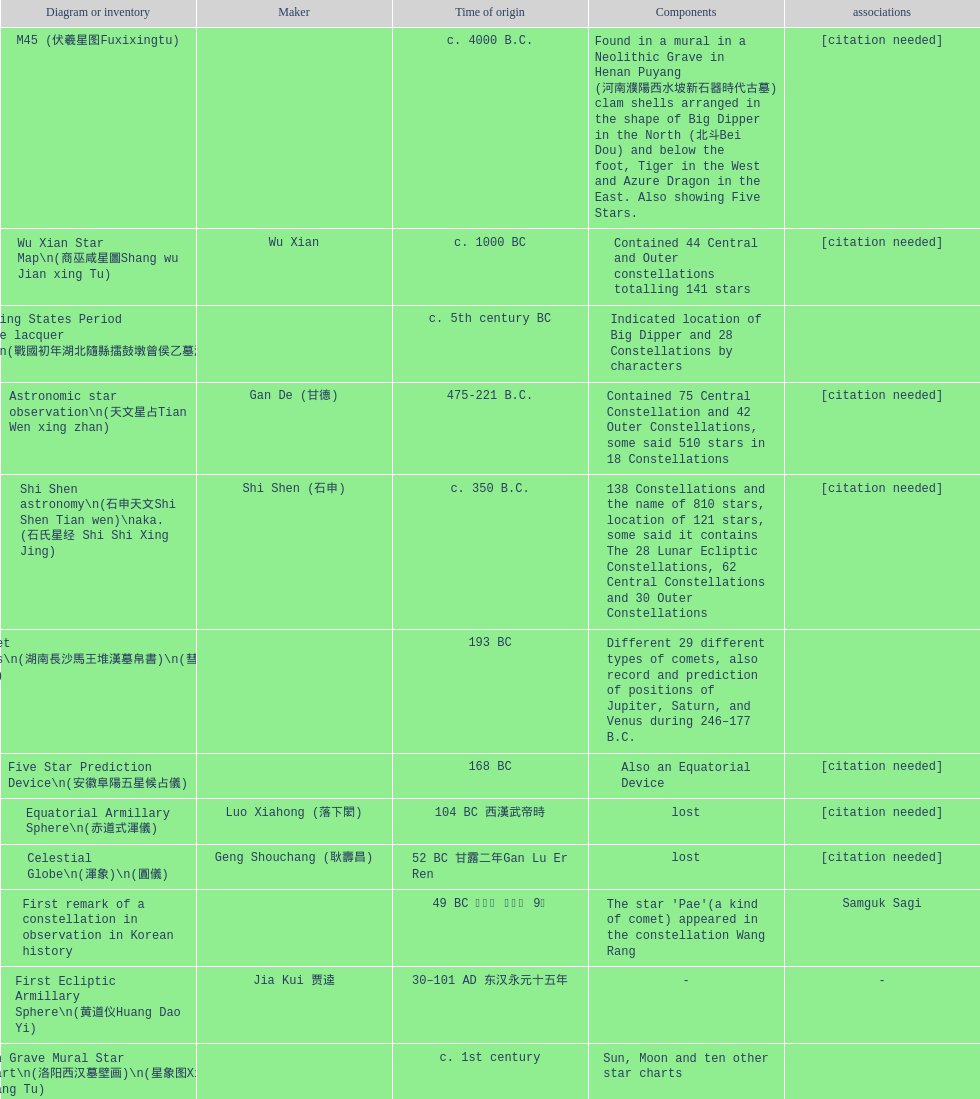What is the name of the oldest map/catalog? M45. 